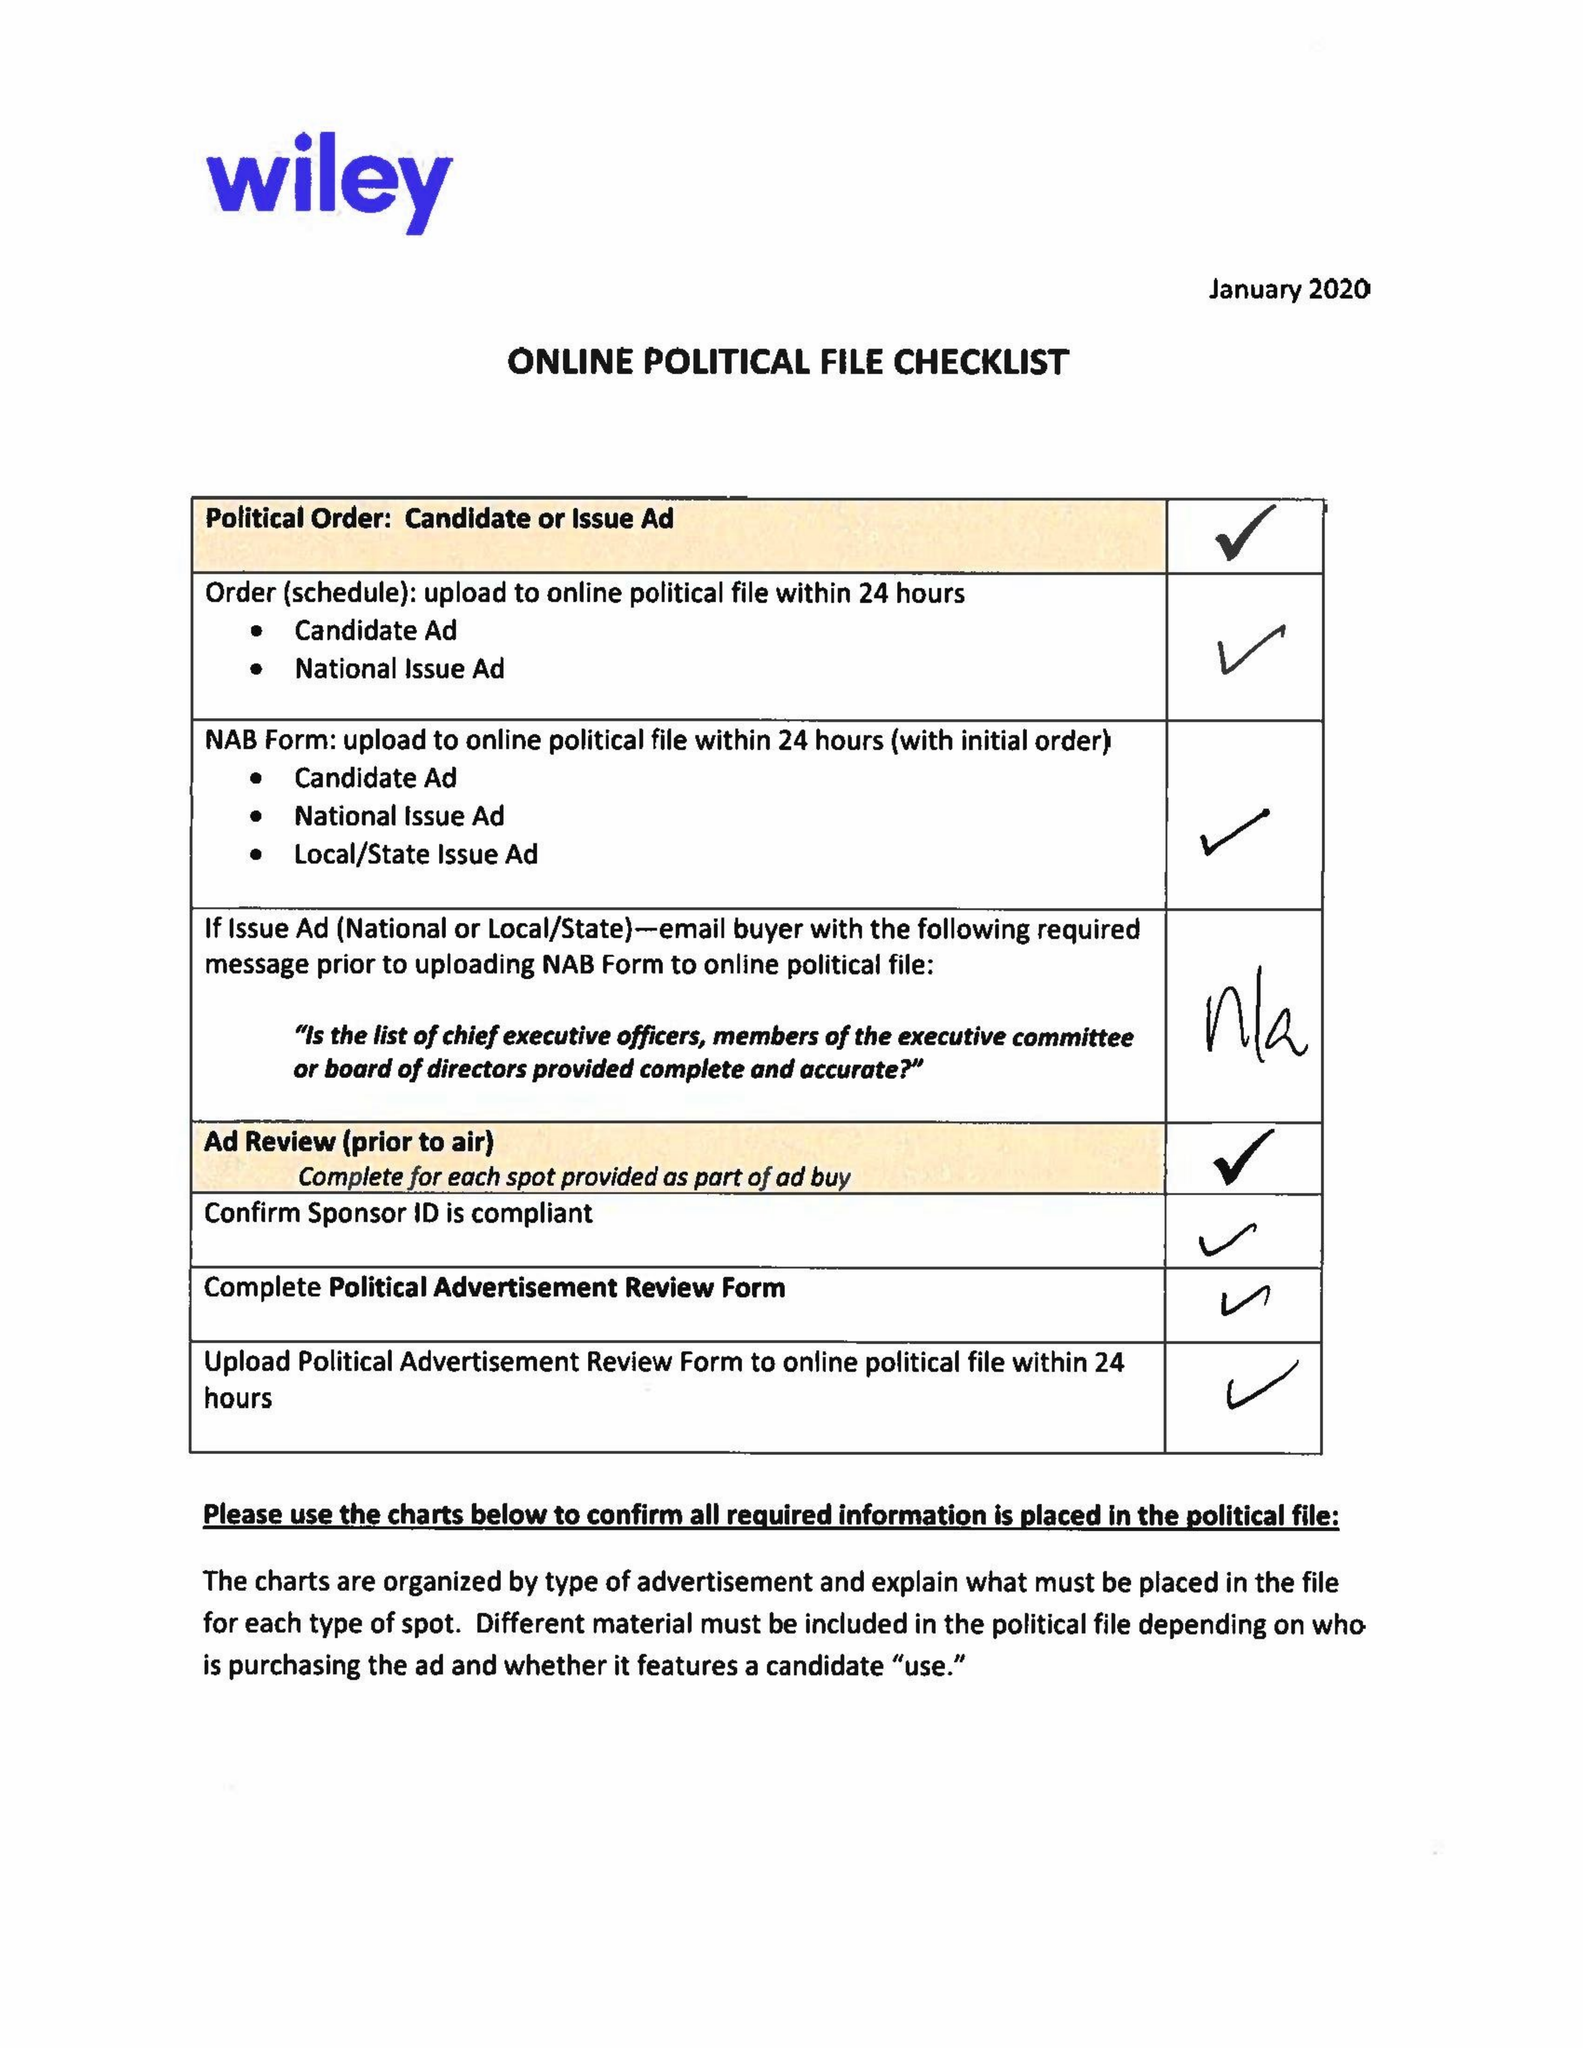What is the value for the contract_num?
Answer the question using a single word or phrase. 1500835 